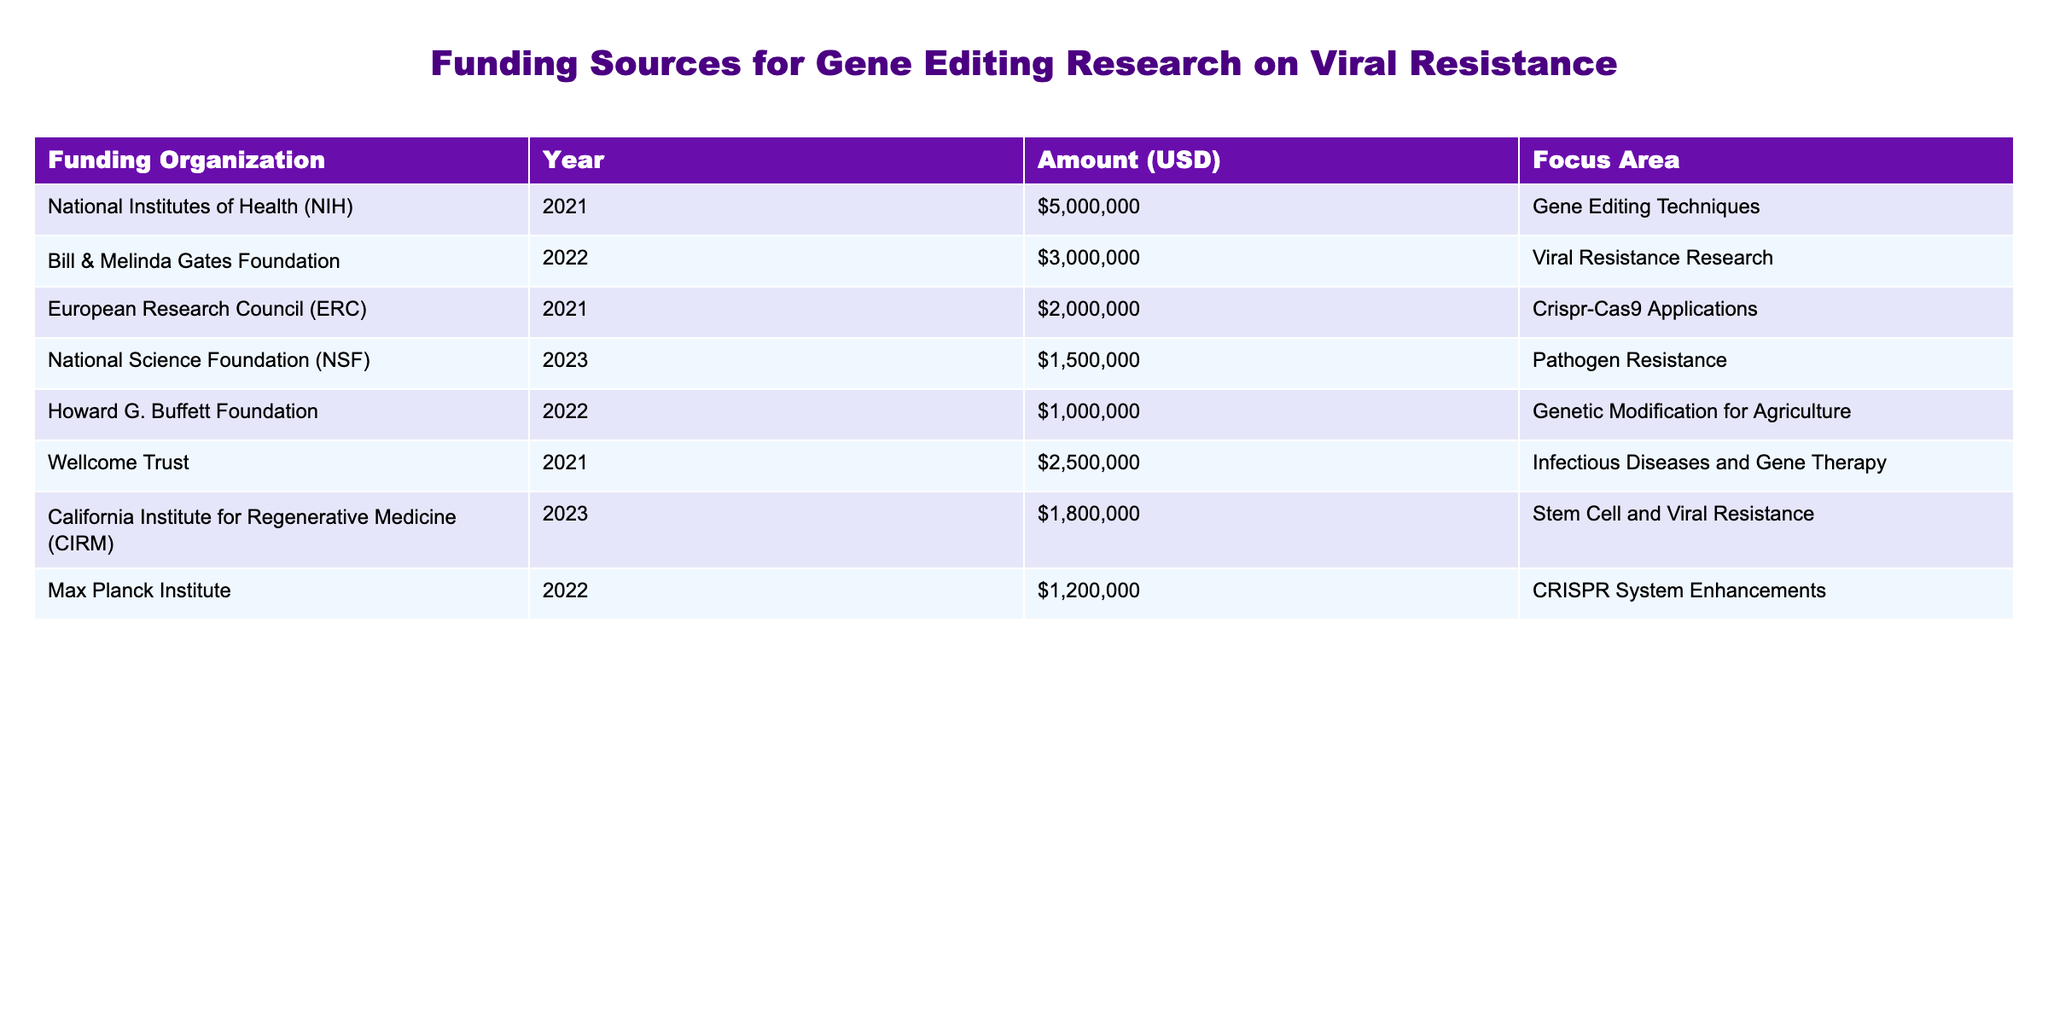What was the total funding amount for gene editing research in 2021? The table indicates funding amounts for various organizations in 2021. I will add the amounts from the National Institutes of Health ($5,000,000), European Research Council ($2,000,000), and Wellcome Trust ($2,500,000). The total is $5,000,000 + $2,000,000 + $2,500,000 = $9,500,000.
Answer: $9,500,000 Which organization provided funding for viral resistance research in 2022? The table shows funding details for 2022. I will look for entries with a "Focus Area" of "Viral Resistance Research" and find that the Bill & Melinda Gates Foundation gave $3,000,000 for that focus area.
Answer: Bill & Melinda Gates Foundation Was there funding for viral resistance research from the California Institute for Regenerative Medicine in 2023? The table specifies that the California Institute for Regenerative Medicine provided $1,800,000 in funding for the "Stem Cell and Viral Resistance" focus area in 2023, confirming a connection to viral resistance.
Answer: Yes What is the average funding amount for gene editing techniques across all years noted? To find the average, I need to identify and sum the funding amounts for "Gene Editing Techniques" and total them. The only entry under this focus is from NIH in 2021 with $5,000,000, making the average also $5,000,000 as there's only one entry.
Answer: $5,000,000 Which funding organization had the highest contribution in the table? By comparing all the funding amounts listed, I find that the National Institutes of Health contributed the highest amount of $5,000,000 for gene editing techniques.
Answer: National Institutes of Health How much total funding was received for research areas related to viral resistance across all listed organizations? I will look for all entries where the "Focus Area" mentions viral resistance. The relevant amounts are $3,000,000 from the Bill & Melinda Gates Foundation and $1,800,000 from the California Institute for Regenerative Medicine, summing these gives $3,000,000 + $1,800,000 = $4,800,000.
Answer: $4,800,000 Did the Max Planck Institute contribute to viral resistance research? Analyzing the table, I see that the Max Planck Institute's focus area is on CRISPR System Enhancements, not viral resistance, therefore confirming that they did not contribute to that area.
Answer: No What is the total funding provided by organizations dedicated to infectious disease-related research? I will check the table for the focus area "Infectious Diseases and Gene Therapy" which is funded by the Wellcome Trust for a total of $2,500,000. There are no other infectious disease-related entries in the table, making the total $2,500,000.
Answer: $2,500,000 